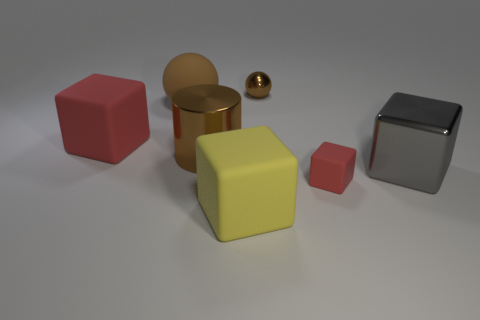Are there any other things of the same shape as the large yellow matte thing?
Offer a very short reply. Yes. Is there any other thing that is the same shape as the big brown metallic object?
Provide a short and direct response. No. There is a big brown ball behind the red thing that is right of the object that is in front of the small red matte thing; what is its material?
Offer a terse response. Rubber. Are there any brown metallic things that have the same size as the yellow cube?
Your response must be concise. Yes. What is the color of the big object that is right of the red cube that is in front of the big gray cube?
Your response must be concise. Gray. What number of big cubes are there?
Provide a succinct answer. 3. Do the rubber ball and the big metal cylinder have the same color?
Keep it short and to the point. Yes. Are there fewer large cylinders that are left of the brown metal cylinder than large blocks that are to the right of the large red cube?
Offer a very short reply. Yes. The metallic sphere has what color?
Offer a very short reply. Brown. What number of things are the same color as the big ball?
Provide a short and direct response. 2. 